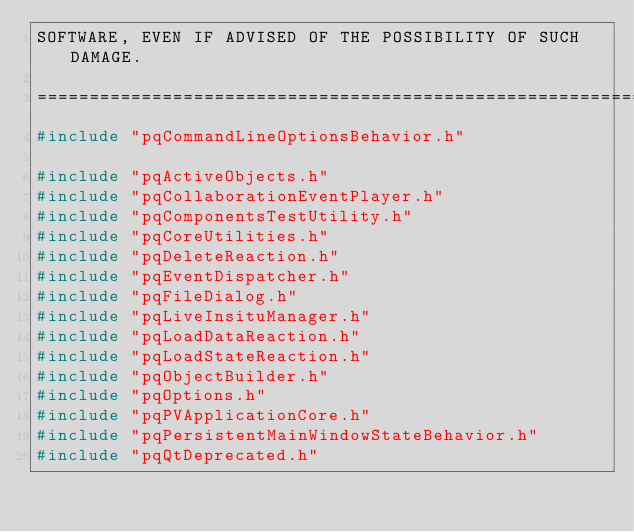Convert code to text. <code><loc_0><loc_0><loc_500><loc_500><_C++_>SOFTWARE, EVEN IF ADVISED OF THE POSSIBILITY OF SUCH DAMAGE.

========================================================================*/
#include "pqCommandLineOptionsBehavior.h"

#include "pqActiveObjects.h"
#include "pqCollaborationEventPlayer.h"
#include "pqComponentsTestUtility.h"
#include "pqCoreUtilities.h"
#include "pqDeleteReaction.h"
#include "pqEventDispatcher.h"
#include "pqFileDialog.h"
#include "pqLiveInsituManager.h"
#include "pqLoadDataReaction.h"
#include "pqLoadStateReaction.h"
#include "pqObjectBuilder.h"
#include "pqOptions.h"
#include "pqPVApplicationCore.h"
#include "pqPersistentMainWindowStateBehavior.h"
#include "pqQtDeprecated.h"</code> 